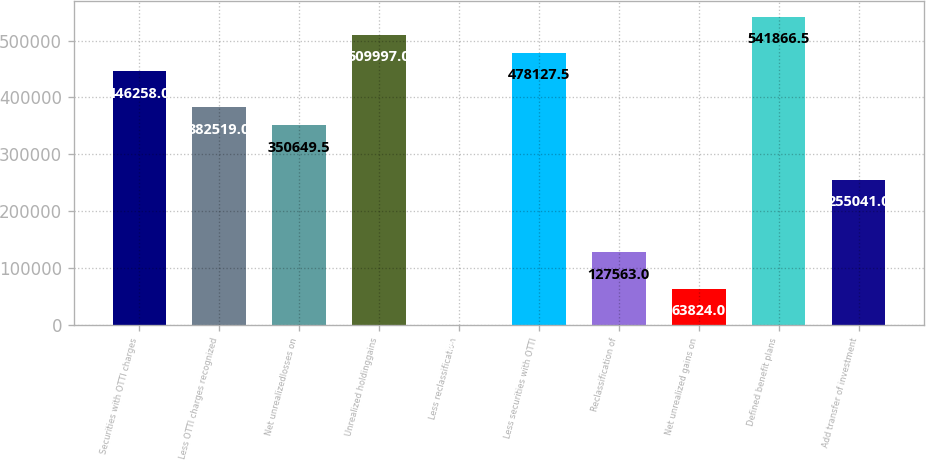Convert chart to OTSL. <chart><loc_0><loc_0><loc_500><loc_500><bar_chart><fcel>Securities with OTTI charges<fcel>Less OTTI charges recognized<fcel>Net unrealizedlosses on<fcel>Unrealized holdinggains<fcel>Less reclassification<fcel>Less securities with OTTI<fcel>Reclassification of<fcel>Net unrealized gains on<fcel>Defined benefit plans<fcel>Add transfer of investment<nl><fcel>446258<fcel>382519<fcel>350650<fcel>509997<fcel>85<fcel>478128<fcel>127563<fcel>63824<fcel>541866<fcel>255041<nl></chart> 